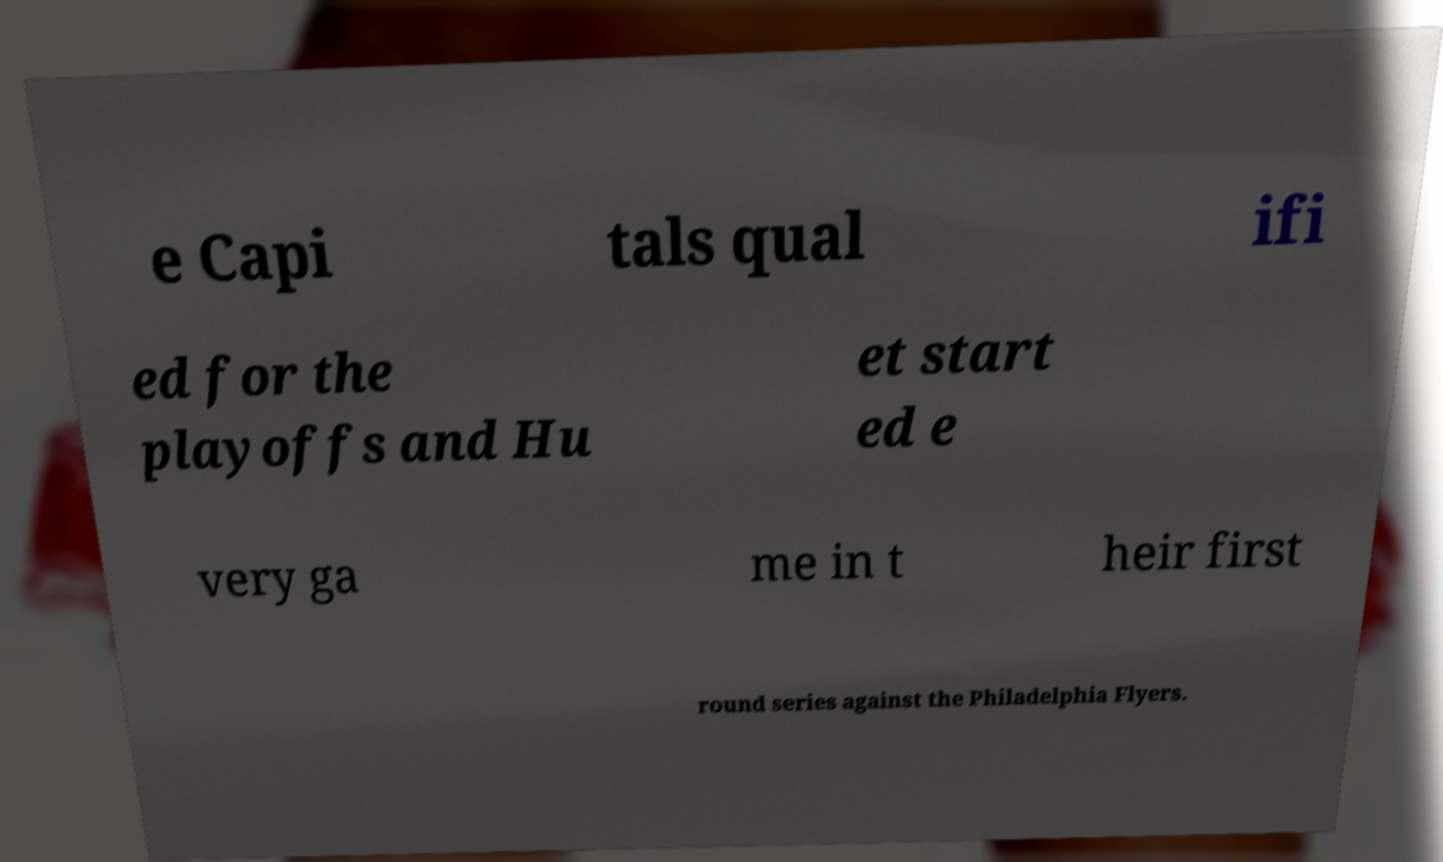There's text embedded in this image that I need extracted. Can you transcribe it verbatim? e Capi tals qual ifi ed for the playoffs and Hu et start ed e very ga me in t heir first round series against the Philadelphia Flyers. 